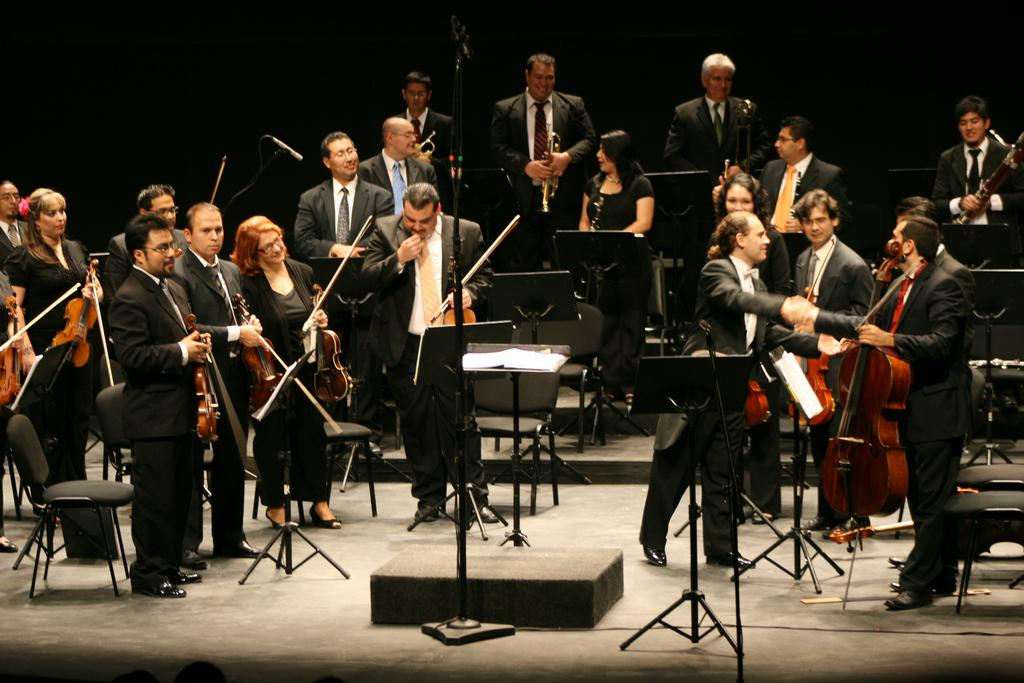What is the main subject of the image? The main subject of the image is a group of people. What are the people in the image doing? The group of people are playing a guitar and a saxophone. What type of drink is being passed around in the image? There is no drink present in the image; it features a group of people playing musical instruments. What type of sock is visible on the foot of one of the musicians? There is no sock visible in the image, as it focuses on the musicians' hands and the instruments they are playing. 